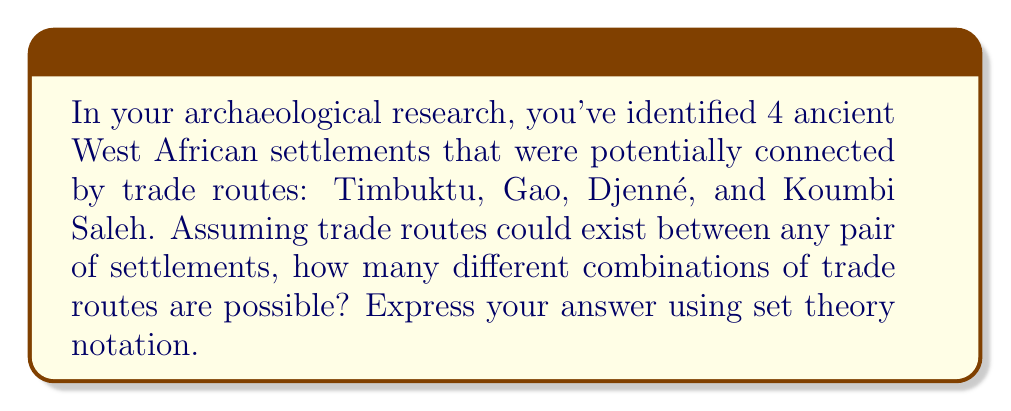What is the answer to this math problem? To solve this problem, we need to consider the power set of all possible trade routes between the settlements. Let's approach this step-by-step:

1) First, let's define our set of settlements:
   $S = \{Timbuktu, Gao, Djenné, Koumbi Saleh\}$

2) Now, we need to consider all possible trade routes. A trade route connects two settlements, so we're looking at all possible pairs of settlements. The number of possible pairs is:

   $\binom{4}{2} = \frac{4!}{2!(4-2)!} = \frac{4 \cdot 3}{2 \cdot 1} = 6$

3) These 6 possible trade routes are:
   $R = \{(Timbuktu, Gao), (Timbuktu, Djenné), (Timbuktu, Koumbi Saleh), (Gao, Djenné), (Gao, Koumbi Saleh), (Djenné, Koumbi Saleh)\}$

4) The question asks for all possible combinations of these trade routes. This is equivalent to finding the power set of $R$, which we denote as $P(R)$.

5) The power set of a set contains all possible subsets of that set, including the empty set and the set itself. For a set with $n$ elements, the power set has $2^n$ elements.

6) In this case, $|R| = 6$, so $|P(R)| = 2^6 = 64$

Therefore, there are 64 different possible combinations of trade routes, including the possibility of no trade routes (empty set) and all trade routes (the set $R$ itself).

In set theory notation, we express this as:

$|P(R)| = 2^{|R|} = 2^6 = 64$

Where $P(R)$ represents the power set of $R$, and $|P(R)|$ is the cardinality (number of elements) of this power set.
Answer: $|P(R)| = 2^6 = 64$ 